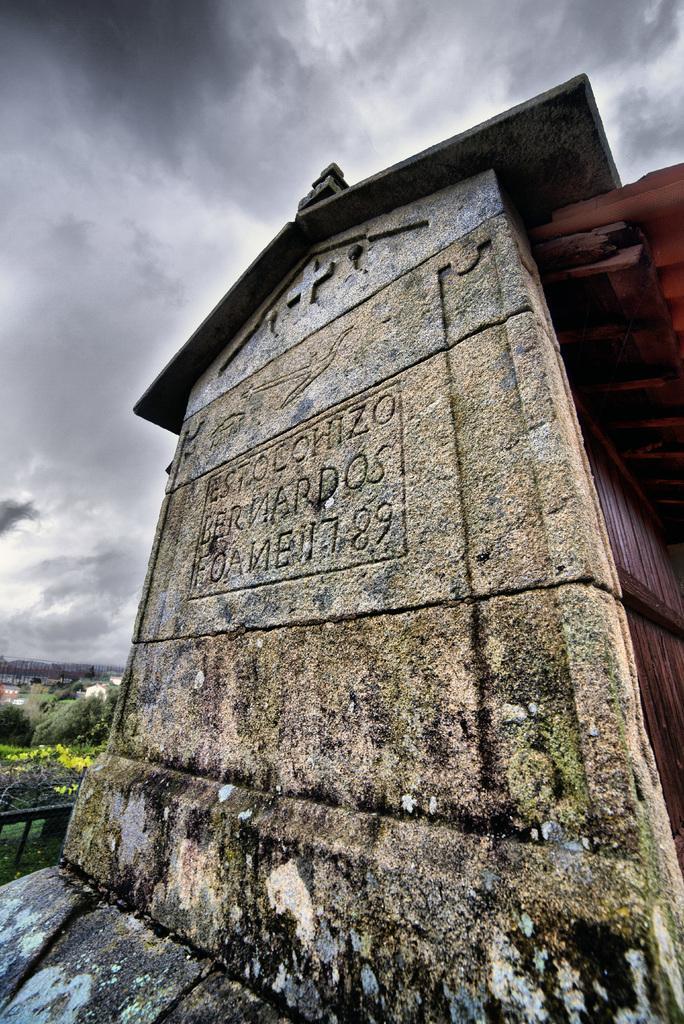How would you summarize this image in a sentence or two? In the picture we can see a stone wall with some wordings are shaped on it and on the top of it, we can see a roof like structure and in the background we can see some grass and a sky with clouds. 